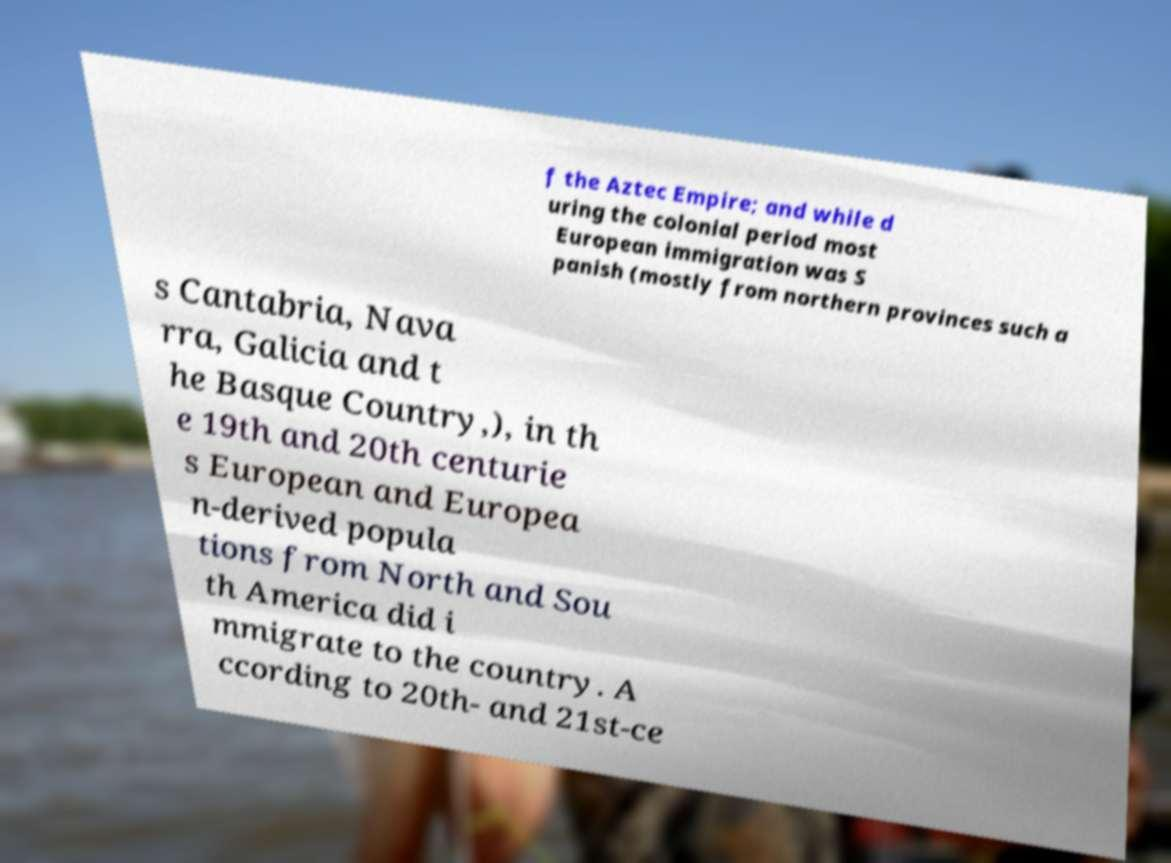What messages or text are displayed in this image? I need them in a readable, typed format. f the Aztec Empire; and while d uring the colonial period most European immigration was S panish (mostly from northern provinces such a s Cantabria, Nava rra, Galicia and t he Basque Country,), in th e 19th and 20th centurie s European and Europea n-derived popula tions from North and Sou th America did i mmigrate to the country. A ccording to 20th- and 21st-ce 